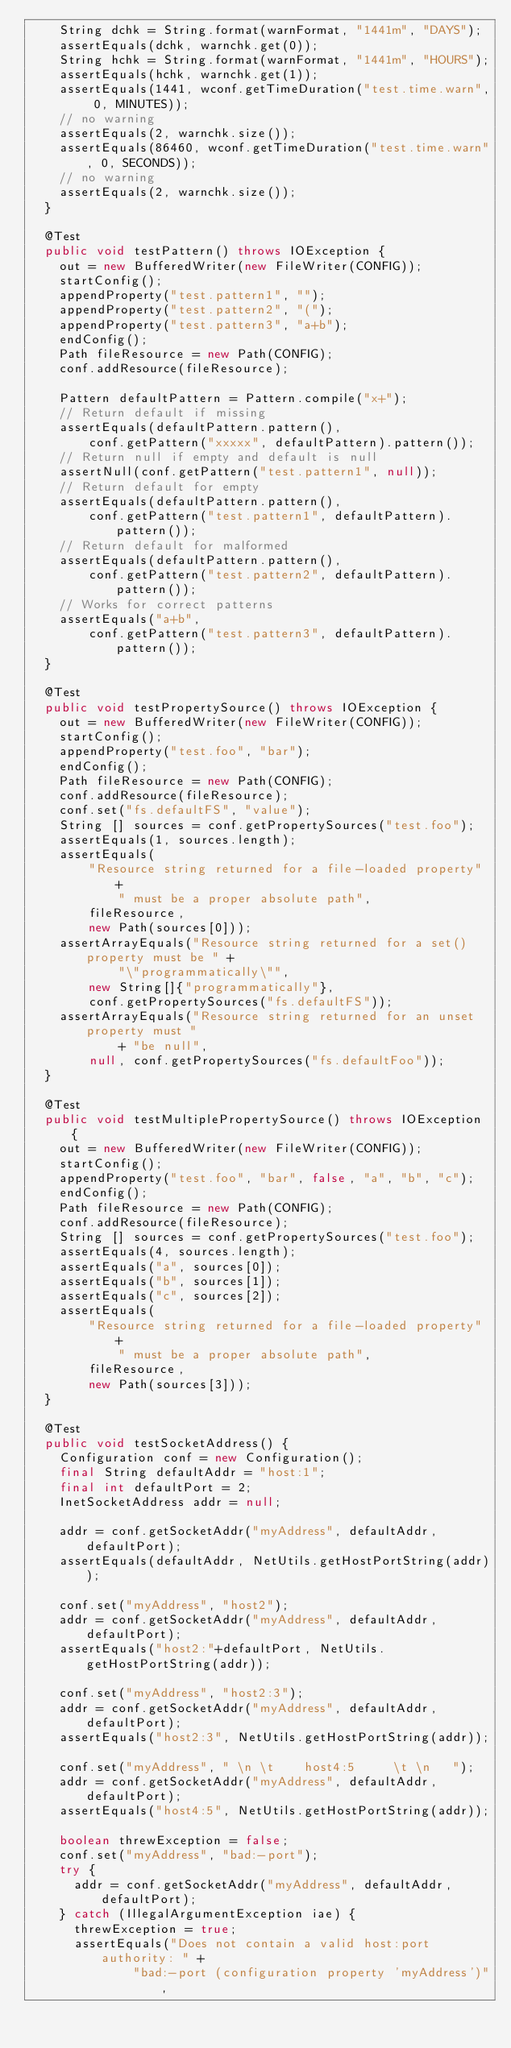Convert code to text. <code><loc_0><loc_0><loc_500><loc_500><_Java_>    String dchk = String.format(warnFormat, "1441m", "DAYS");
    assertEquals(dchk, warnchk.get(0));
    String hchk = String.format(warnFormat, "1441m", "HOURS");
    assertEquals(hchk, warnchk.get(1));
    assertEquals(1441, wconf.getTimeDuration("test.time.warn", 0, MINUTES));
    // no warning
    assertEquals(2, warnchk.size());
    assertEquals(86460, wconf.getTimeDuration("test.time.warn", 0, SECONDS));
    // no warning
    assertEquals(2, warnchk.size());
  }

  @Test
  public void testPattern() throws IOException {
    out = new BufferedWriter(new FileWriter(CONFIG));
    startConfig();
    appendProperty("test.pattern1", "");
    appendProperty("test.pattern2", "(");
    appendProperty("test.pattern3", "a+b");
    endConfig();
    Path fileResource = new Path(CONFIG);
    conf.addResource(fileResource);

    Pattern defaultPattern = Pattern.compile("x+");
    // Return default if missing
    assertEquals(defaultPattern.pattern(),
        conf.getPattern("xxxxx", defaultPattern).pattern());
    // Return null if empty and default is null
    assertNull(conf.getPattern("test.pattern1", null));
    // Return default for empty
    assertEquals(defaultPattern.pattern(),
        conf.getPattern("test.pattern1", defaultPattern).pattern());
    // Return default for malformed
    assertEquals(defaultPattern.pattern(),
        conf.getPattern("test.pattern2", defaultPattern).pattern());
    // Works for correct patterns
    assertEquals("a+b",
        conf.getPattern("test.pattern3", defaultPattern).pattern());
  }

  @Test
  public void testPropertySource() throws IOException {
    out = new BufferedWriter(new FileWriter(CONFIG));
    startConfig();
    appendProperty("test.foo", "bar");
    endConfig();
    Path fileResource = new Path(CONFIG);
    conf.addResource(fileResource);
    conf.set("fs.defaultFS", "value");
    String [] sources = conf.getPropertySources("test.foo");
    assertEquals(1, sources.length);
    assertEquals(
        "Resource string returned for a file-loaded property" +
            " must be a proper absolute path",
        fileResource,
        new Path(sources[0]));
    assertArrayEquals("Resource string returned for a set() property must be " +
            "\"programmatically\"",
        new String[]{"programmatically"},
        conf.getPropertySources("fs.defaultFS"));
    assertArrayEquals("Resource string returned for an unset property must "
            + "be null",
        null, conf.getPropertySources("fs.defaultFoo"));
  }

  @Test
  public void testMultiplePropertySource() throws IOException {
    out = new BufferedWriter(new FileWriter(CONFIG));
    startConfig();
    appendProperty("test.foo", "bar", false, "a", "b", "c");
    endConfig();
    Path fileResource = new Path(CONFIG);
    conf.addResource(fileResource);
    String [] sources = conf.getPropertySources("test.foo");
    assertEquals(4, sources.length);
    assertEquals("a", sources[0]);
    assertEquals("b", sources[1]);
    assertEquals("c", sources[2]);
    assertEquals(
        "Resource string returned for a file-loaded property" +
            " must be a proper absolute path",
        fileResource,
        new Path(sources[3]));
  }

  @Test
  public void testSocketAddress() {
    Configuration conf = new Configuration();
    final String defaultAddr = "host:1";
    final int defaultPort = 2;
    InetSocketAddress addr = null;

    addr = conf.getSocketAddr("myAddress", defaultAddr, defaultPort);
    assertEquals(defaultAddr, NetUtils.getHostPortString(addr));

    conf.set("myAddress", "host2");
    addr = conf.getSocketAddr("myAddress", defaultAddr, defaultPort);
    assertEquals("host2:"+defaultPort, NetUtils.getHostPortString(addr));

    conf.set("myAddress", "host2:3");
    addr = conf.getSocketAddr("myAddress", defaultAddr, defaultPort);
    assertEquals("host2:3", NetUtils.getHostPortString(addr));

    conf.set("myAddress", " \n \t    host4:5     \t \n   ");
    addr = conf.getSocketAddr("myAddress", defaultAddr, defaultPort);
    assertEquals("host4:5", NetUtils.getHostPortString(addr));

    boolean threwException = false;
    conf.set("myAddress", "bad:-port");
    try {
      addr = conf.getSocketAddr("myAddress", defaultAddr, defaultPort);
    } catch (IllegalArgumentException iae) {
      threwException = true;
      assertEquals("Does not contain a valid host:port authority: " +
              "bad:-port (configuration property 'myAddress')",</code> 